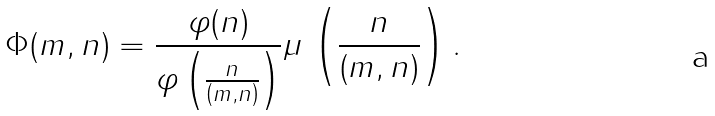Convert formula to latex. <formula><loc_0><loc_0><loc_500><loc_500>\Phi ( m , n ) = \frac { \varphi ( n ) } { \varphi \left ( \frac { n } { \left ( m , n \right ) } \right ) } \mu \, \left ( \frac { n } { \left ( m , n \right ) } \right ) .</formula> 